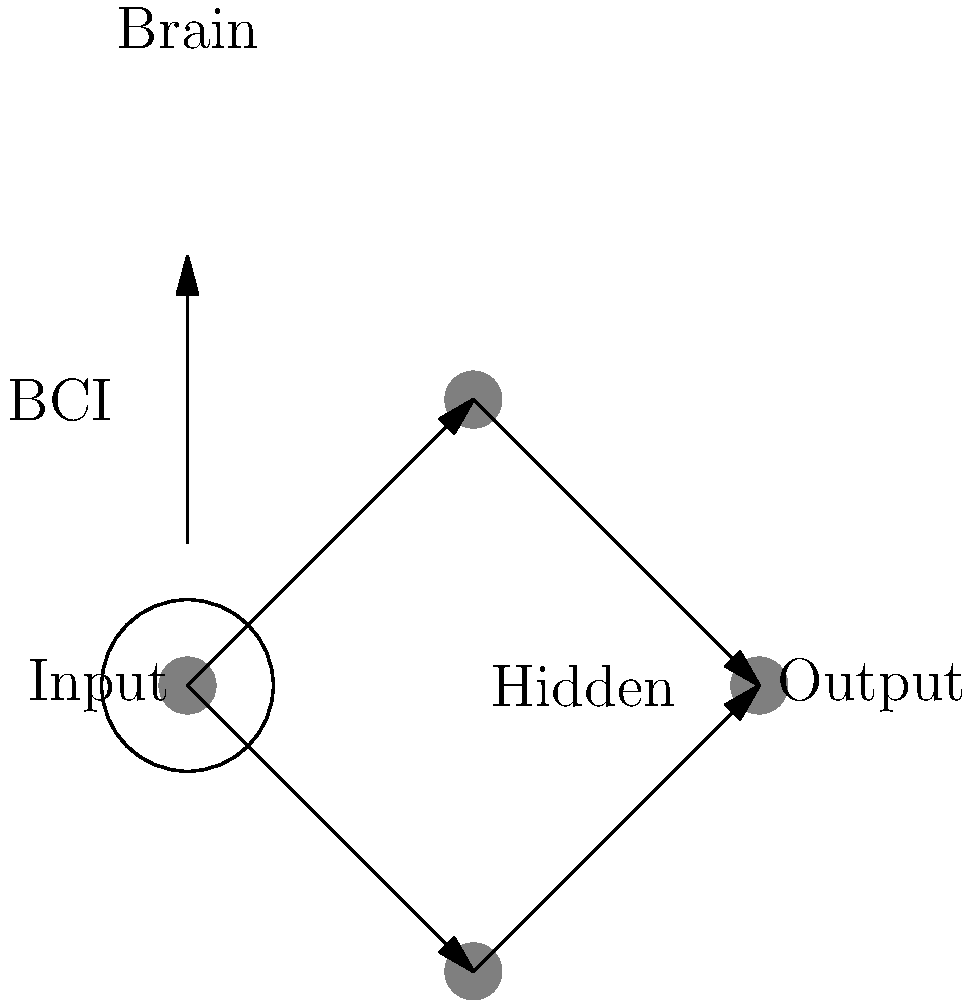In the context of a brain-computer interface (BCI) for a transhumanist neural enhancement, how does the biomechanical process of neural signal propagation differ from the information flow in the simplified artificial neural network shown? Consider the implications for signal latency and information processing in both biological and artificial systems. To answer this question, let's break down the process step-by-step:

1. Biological neural signal propagation:
   a. Neurons in the brain communicate via electrochemical signals.
   b. Signal transmission occurs through action potentials along axons.
   c. Synaptic transmission involves neurotransmitter release and receptor activation.
   d. Typical conduction velocities range from 0.5 to 120 m/s.

2. Artificial neural network signal propagation:
   a. Information flows through weighted connections between artificial neurons.
   b. Signals are purely electrical and propagate at near light speed.
   c. Processing occurs through mathematical operations (e.g., dot products, activation functions).
   d. Signal transmission is near-instantaneous compared to biological neurons.

3. BCI interface considerations:
   a. BCIs must convert biological signals to digital information.
   b. This conversion introduces a delay and potential loss of information.
   c. The interface must account for the differences in signal types and speeds.

4. Implications for signal latency:
   a. Biological systems have higher latency due to slower signal propagation.
   b. Artificial systems have minimal latency but may lack the complexity of biological networks.
   c. BCIs must balance the speed of artificial systems with the richness of biological information.

5. Information processing differences:
   a. Biological neurons can process information in a highly parallel and adaptive manner.
   b. Artificial neurons in the diagram show a simplified feedforward structure.
   c. BCIs must translate between the complex, adaptive biological processing and the more structured artificial processing.

The key difference lies in the nature of the signals (electrochemical vs. electrical) and the resulting impact on speed and information complexity. BCIs must bridge this gap, potentially leading to novel hybrid systems that combine the strengths of both biological and artificial neural networks.
Answer: Biological neurons use slower electrochemical signals with complex processing, while artificial networks use faster electrical signals with simpler processing. BCIs must bridge this gap. 